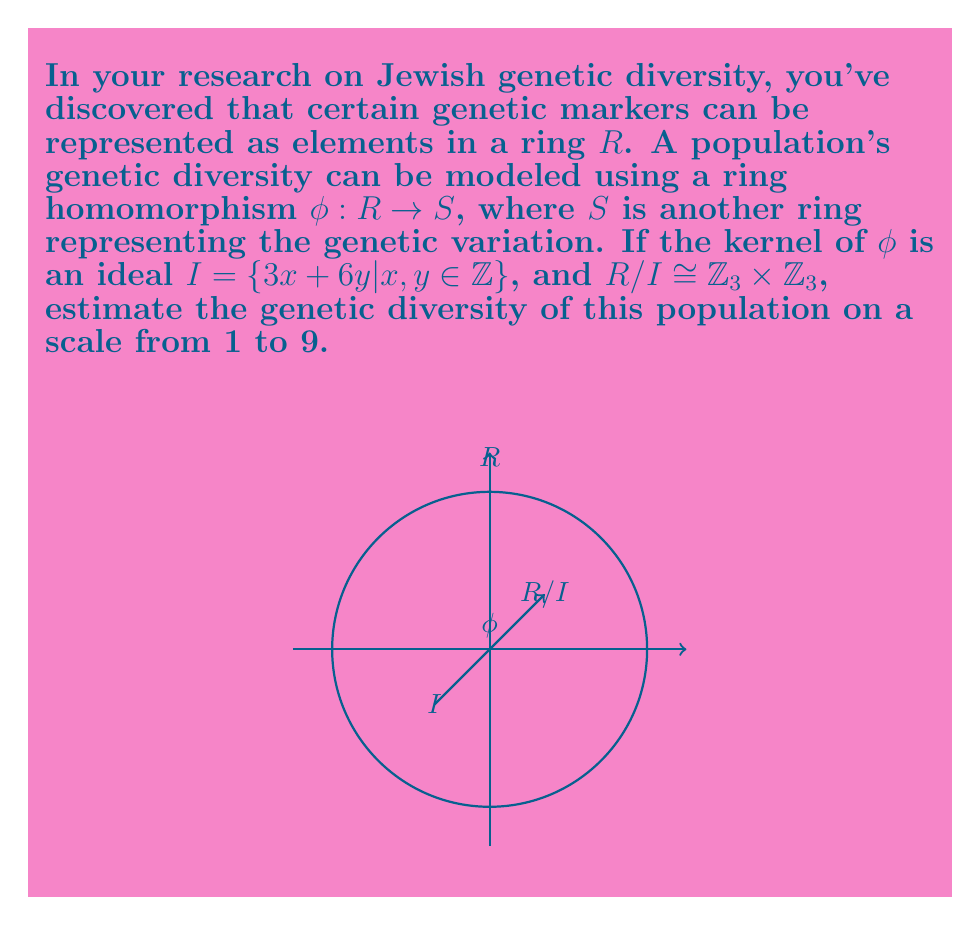Teach me how to tackle this problem. Let's approach this step-by-step:

1) The kernel of $\phi$ is an ideal $I = \{3x + 6y | x, y \in \mathbb{Z}\}$. This represents the genetic markers that are "nullified" in the mapping.

2) We're given that $R/I \cong \mathbb{Z}_3 \times \mathbb{Z}_3$. This isomorphism tells us about the structure of the quotient ring.

3) $\mathbb{Z}_3 \times \mathbb{Z}_3$ has $3 \times 3 = 9$ elements. This represents the number of distinct genetic variations in the population after accounting for the "nullified" markers.

4) In ring theory, the First Isomorphism Theorem states that for a ring homomorphism $\phi: R \rightarrow S$, we have $R/\text{ker}(\phi) \cong \text{im}(\phi)$.

5) Therefore, $\text{im}(\phi) \cong \mathbb{Z}_3 \times \mathbb{Z}_3$, which means the image of $\phi$ has 9 elements.

6) The size of $\text{im}(\phi)$ represents the genetic diversity of the population. A larger image means more genetic variations.

7) Since we're asked to estimate the genetic diversity on a scale from 1 to 9, and we've found that there are 9 distinct genetic variations, we can conclude that this population has the maximum possible genetic diversity on this scale.
Answer: 9 